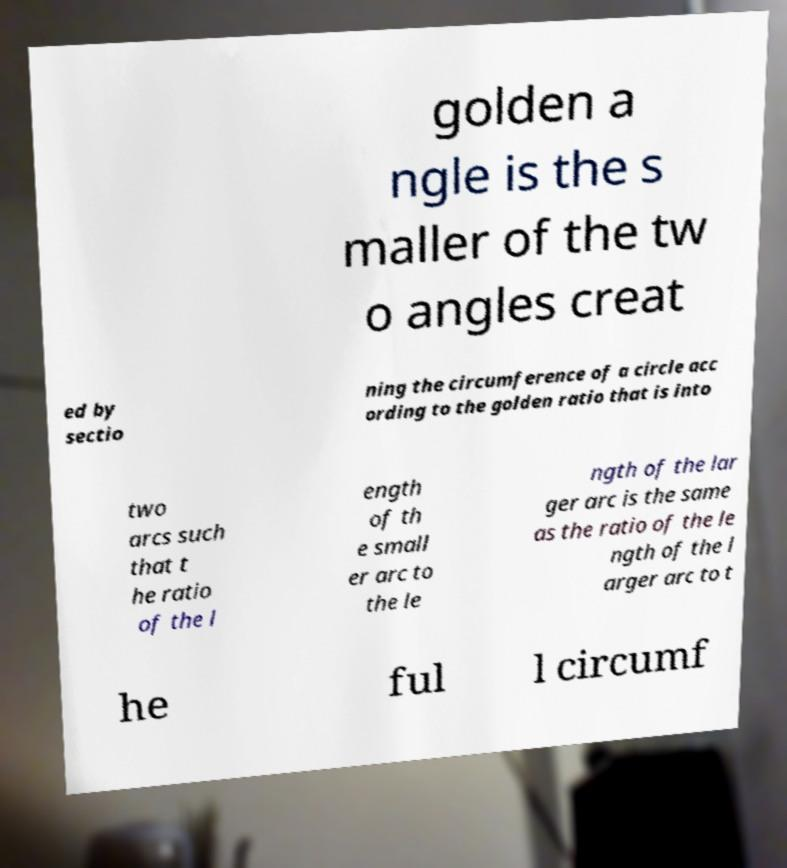Can you read and provide the text displayed in the image?This photo seems to have some interesting text. Can you extract and type it out for me? golden a ngle is the s maller of the tw o angles creat ed by sectio ning the circumference of a circle acc ording to the golden ratio that is into two arcs such that t he ratio of the l ength of th e small er arc to the le ngth of the lar ger arc is the same as the ratio of the le ngth of the l arger arc to t he ful l circumf 